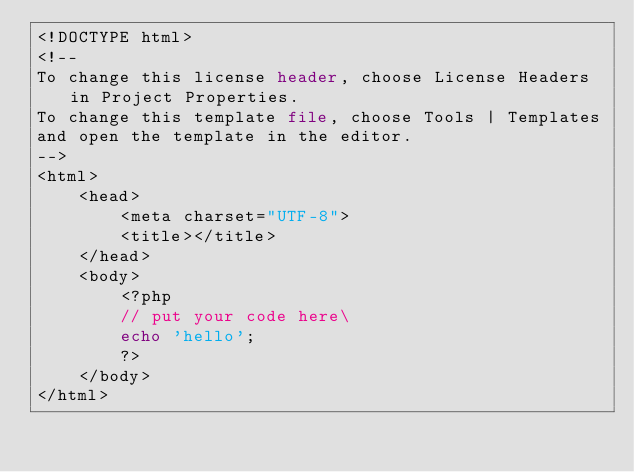<code> <loc_0><loc_0><loc_500><loc_500><_PHP_><!DOCTYPE html>
<!--
To change this license header, choose License Headers in Project Properties.
To change this template file, choose Tools | Templates
and open the template in the editor.
-->
<html>
    <head>
        <meta charset="UTF-8">
        <title></title>
    </head>
    <body>
        <?php
        // put your code here\
        echo 'hello';
        ?>
    </body>
</html>
</code> 